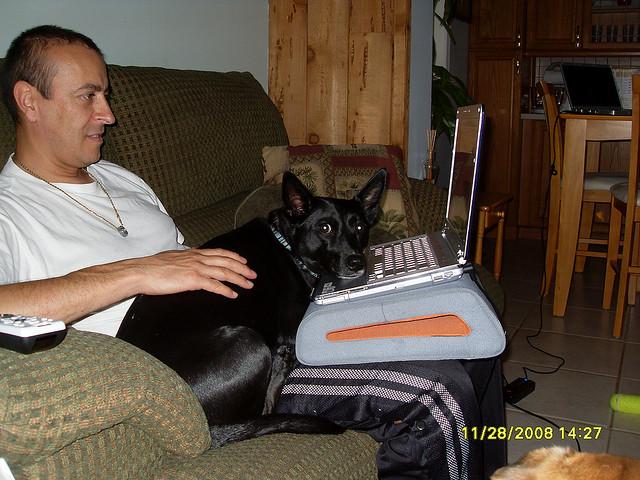Where is the dog sitting?
Write a very short answer. Couch. What color is the dog?
Keep it brief. Black. Does this chair have wheels?
Quick response, please. No. Is the man wearing a shirt?
Give a very brief answer. Yes. Is there a woman in the photo?
Be succinct. No. Is this a woman?
Concise answer only. No. 